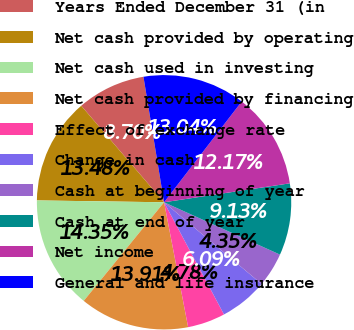Convert chart to OTSL. <chart><loc_0><loc_0><loc_500><loc_500><pie_chart><fcel>Years Ended December 31 (in<fcel>Net cash provided by operating<fcel>Net cash used in investing<fcel>Net cash provided by financing<fcel>Effect of exchange rate<fcel>Change in cash<fcel>Cash at beginning of year<fcel>Cash at end of year<fcel>Net income<fcel>General and life insurance<nl><fcel>8.7%<fcel>13.48%<fcel>14.35%<fcel>13.91%<fcel>4.78%<fcel>6.09%<fcel>4.35%<fcel>9.13%<fcel>12.17%<fcel>13.04%<nl></chart> 